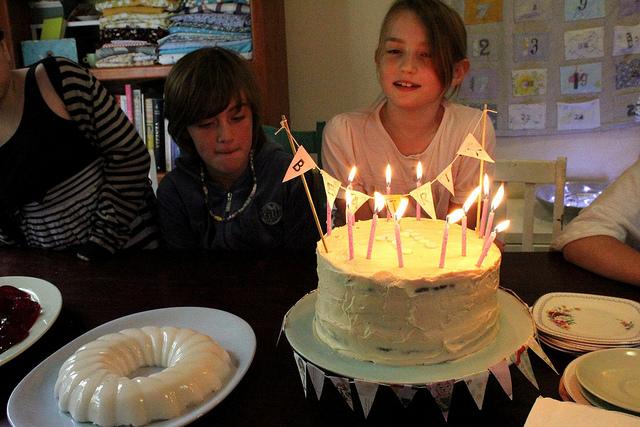What numbers are on the cupcakes?
Give a very brief answer. 0. What kind of food is this?
Be succinct. Cake. How many pieces is the cake cut into?
Concise answer only. 0. How old is the person celebrating their birthday?
Concise answer only. 12. What is the theme of the party?
Short answer required. Birthday. Where are the candles?
Concise answer only. On cake. How many cakes in the shot?
Write a very short answer. 1. Are there candles on the cake?
Be succinct. Yes. What kind of food is shown?
Answer briefly. Cake. What color is the jell-o mold?
Keep it brief. White. 